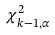<formula> <loc_0><loc_0><loc_500><loc_500>\chi _ { k - 1 , \alpha } ^ { 2 }</formula> 